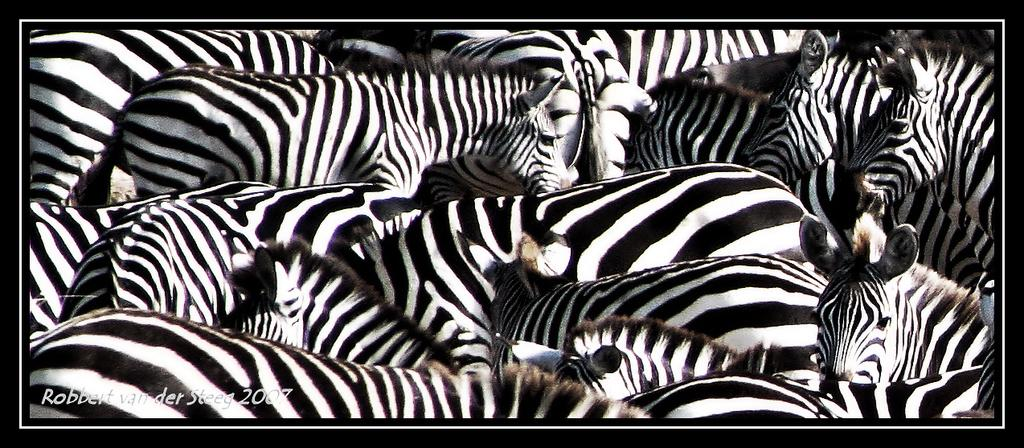What animals are present in the image? There are zebras in the image. What else can be seen in the image besides the zebras? There is text and numbers in the image. Where are the text and numbers located in the image? The text and numbers are located in the bottom left of the image. What type of seed is being stored in the tin in the image? There is no tin or seed present in the image; it features zebras, text, and numbers. 